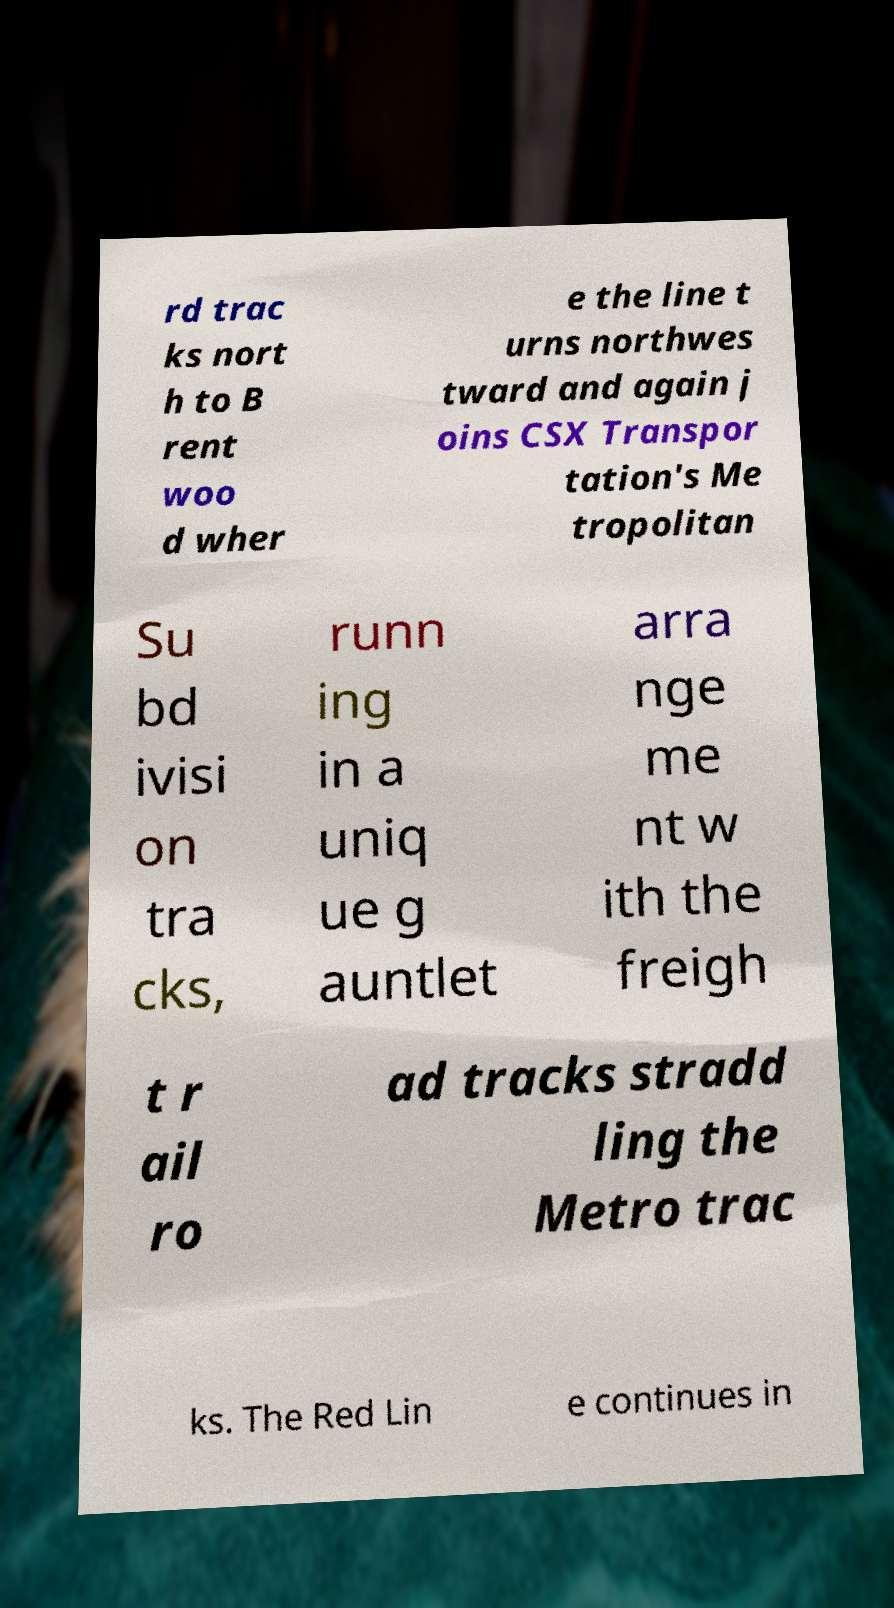Can you accurately transcribe the text from the provided image for me? rd trac ks nort h to B rent woo d wher e the line t urns northwes tward and again j oins CSX Transpor tation's Me tropolitan Su bd ivisi on tra cks, runn ing in a uniq ue g auntlet arra nge me nt w ith the freigh t r ail ro ad tracks stradd ling the Metro trac ks. The Red Lin e continues in 